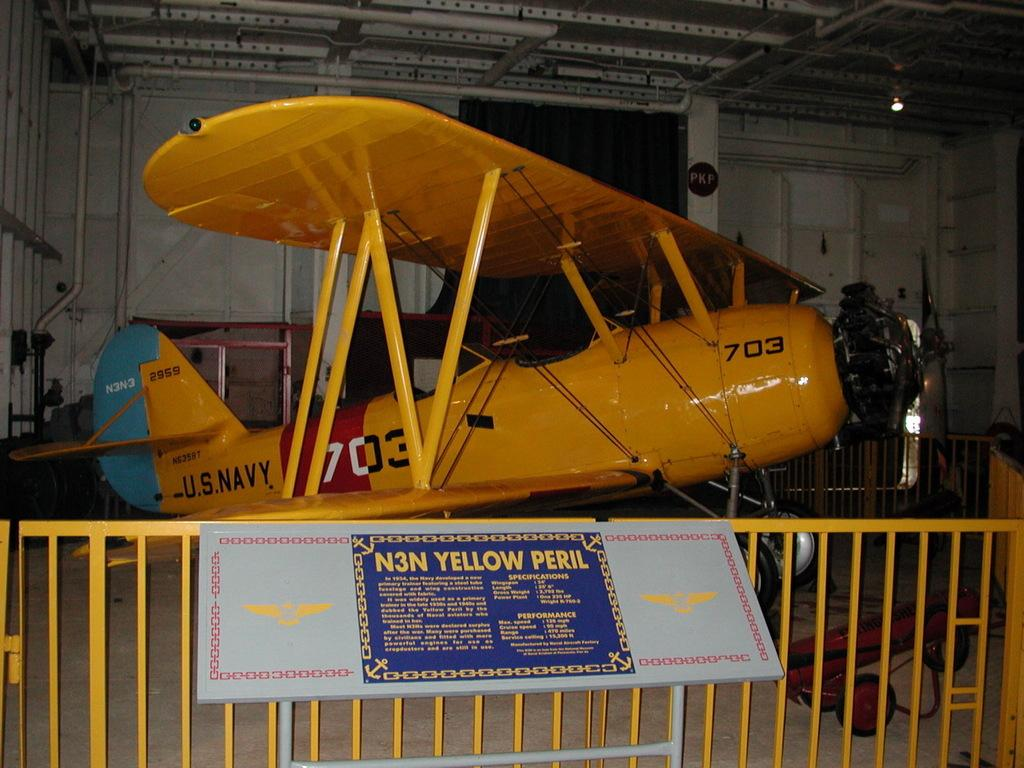<image>
Describe the image concisely. An old bright yellow aeroplane with the number 703 on its fuselage 